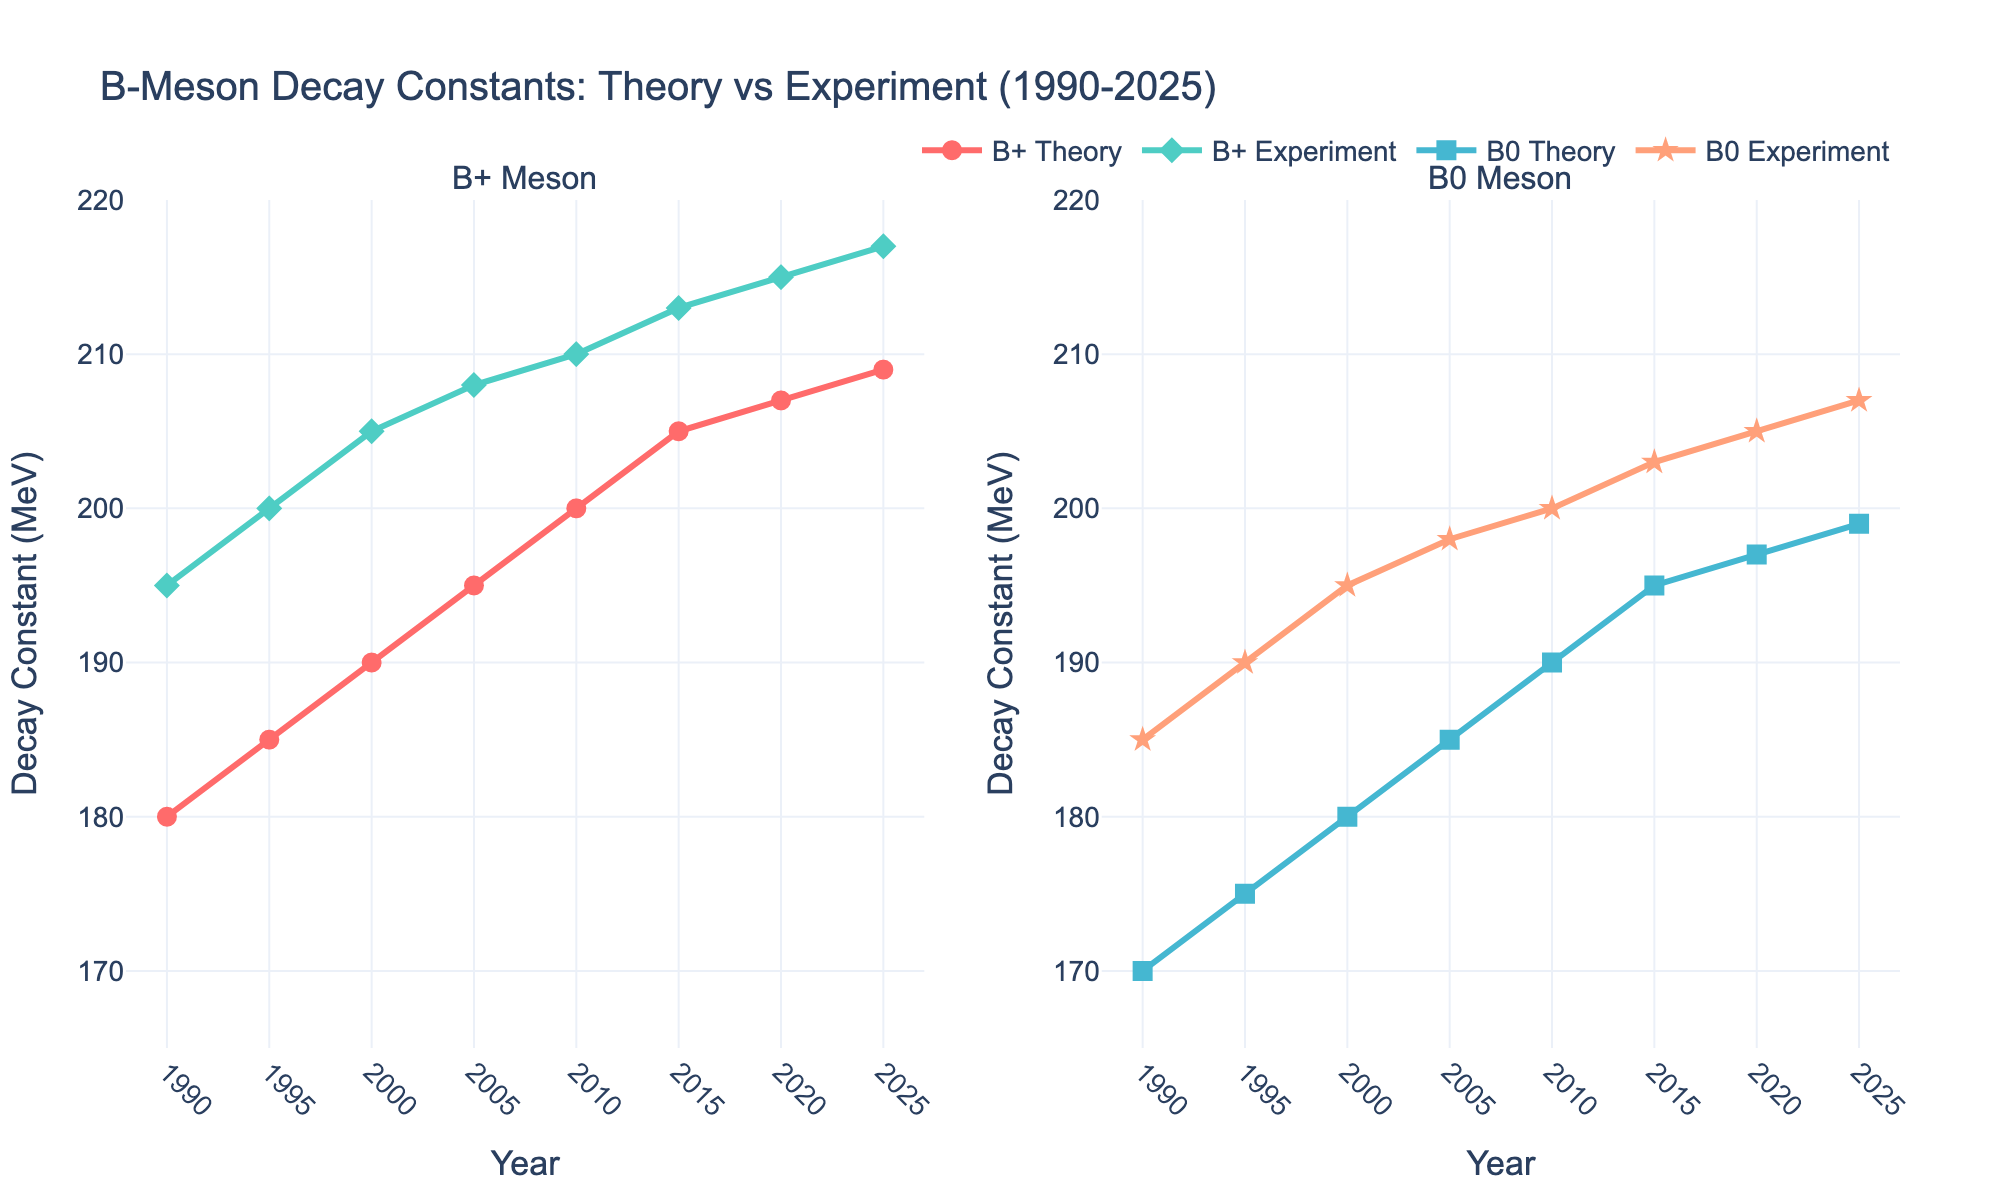What is the difference between the theoretical prediction and experimental result for fB+ in the year 2000? The value for fB+ (Theory) in 2000 is 190 MeV and the value for fB+ (Experiment) is 205 MeV. The difference is 205 - 190 = 15 MeV.
Answer: 15 MeV In which year did the fB0 (Experiment) surpass 200 MeV? By examining the fB0 (Experiment) values across years, it can be observed that the value exceeds 200 MeV in the year 2010.
Answer: 2010 Is the trend for fB+ (Theory) increasing or decreasing over the years shown? By observing the values from 1990 to 2025, it's clear that the fB+ (Theory) values are increasing over the years.
Answer: Increasing Which has a higher value in 2020: fB0 (Theory) or fB0 (Experiment)? The value for fB0 (Theory) in 2020 is 197 MeV, while the fB0 (Experiment) is 205 MeV. Therefore, the fB0 (Experiment) has a higher value.
Answer: fB0 (Experiment) What's the average value of fB0 (Theory) for the years 2000, 2005, and 2010? The fB0 (Theory) values for the years 2000, 2005, and 2010 are 180, 185, and 190 MeV respectively. The average value is (180 + 185 + 190) / 3 = 185 MeV.
Answer: 185 MeV Does the experimental result for fB+ ever equal its theoretical prediction? If so, in which year(s)? By comparing the fB+ (Theory) and fB+ (Experiment) values across the years, there is no year where their values are equal.
Answer: No Between 1995 and 2005, which has a smaller increase: fB+ (Theory) or fB0 (Experiment)? fB+ (Theory) increases from 185 MeV in 1995 to 195 MeV in 2005, which is a 10 MeV increase. fB0 (Experiment) increases from 190 MeV in 1995 to 198 MeV in 2005, which is an 8 MeV increase. Hence, fB0 (Experiment) has a smaller increase.
Answer: fB0 (Experiment) How are the markers for fB+ (Experiment) and fB0 (Theory) visually distinguished? The markers for fB+ (Experiment) are diamond-shaped, while the markers for fB0 (Theory) are square-shaped.
Answer: Diamond for fB+ (Experiment), Square for fB0 (Theory) 